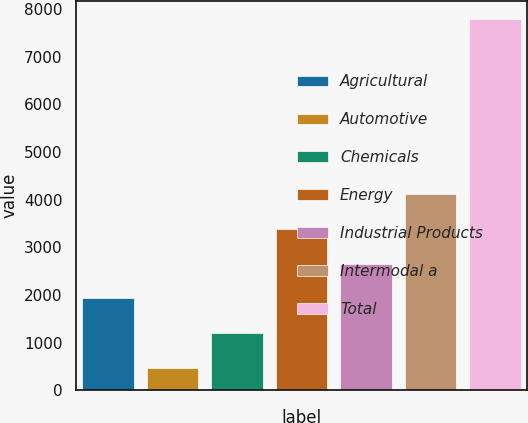Convert chart. <chart><loc_0><loc_0><loc_500><loc_500><bar_chart><fcel>Agricultural<fcel>Automotive<fcel>Chemicals<fcel>Energy<fcel>Industrial Products<fcel>Intermodal a<fcel>Total<nl><fcel>1929.2<fcel>465<fcel>1197.1<fcel>3393.4<fcel>2661.3<fcel>4125.5<fcel>7786<nl></chart> 